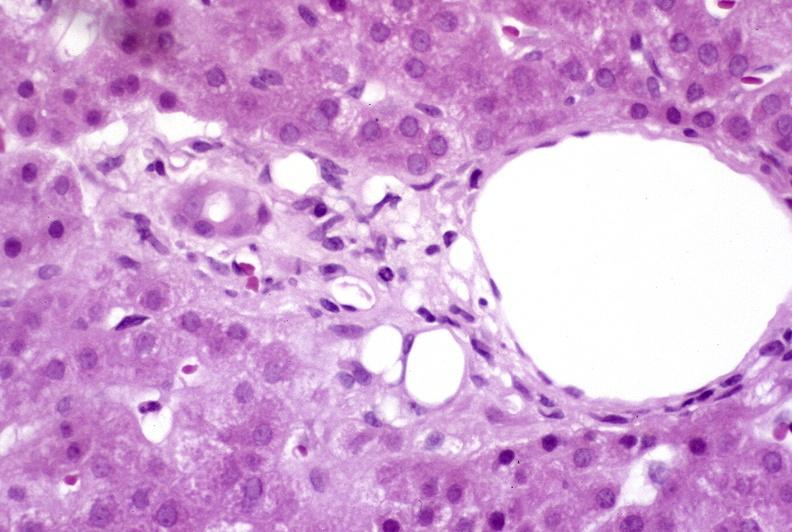what does this image show?
Answer the question using a single word or phrase. Recovery of ducts 